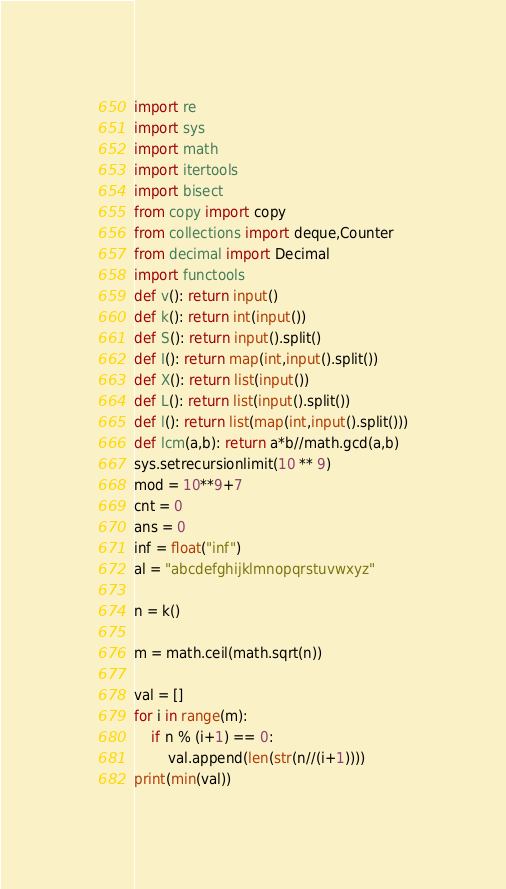<code> <loc_0><loc_0><loc_500><loc_500><_Python_>import re
import sys
import math
import itertools
import bisect
from copy import copy
from collections import deque,Counter
from decimal import Decimal
import functools
def v(): return input()
def k(): return int(input())
def S(): return input().split()
def I(): return map(int,input().split())
def X(): return list(input())
def L(): return list(input().split())
def l(): return list(map(int,input().split()))
def lcm(a,b): return a*b//math.gcd(a,b)
sys.setrecursionlimit(10 ** 9)
mod = 10**9+7
cnt = 0
ans = 0
inf = float("inf")
al = "abcdefghijklmnopqrstuvwxyz"

n = k()

m = math.ceil(math.sqrt(n))

val = []
for i in range(m):
    if n % (i+1) == 0:
        val.append(len(str(n//(i+1))))
print(min(val))
</code> 